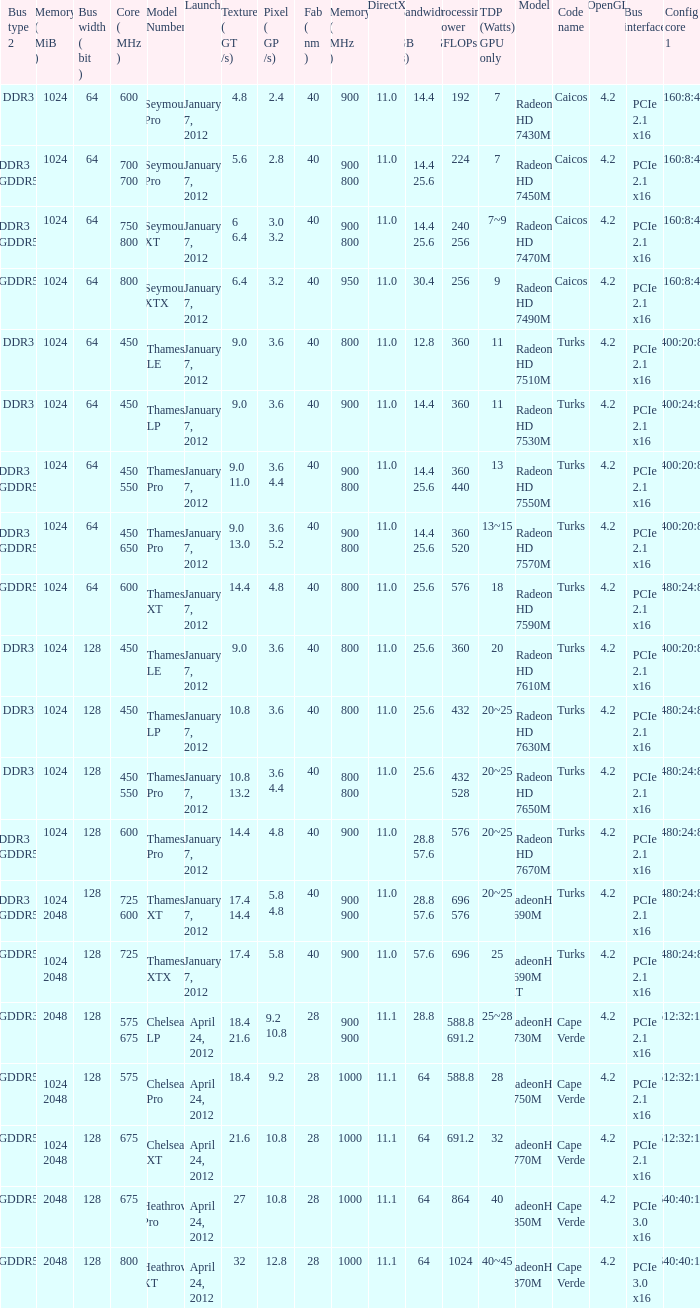What is the config core 1 of the model with a processing power GFLOPs of 432? 480:24:8. 